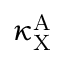<formula> <loc_0><loc_0><loc_500><loc_500>\kappa _ { X } ^ { A }</formula> 